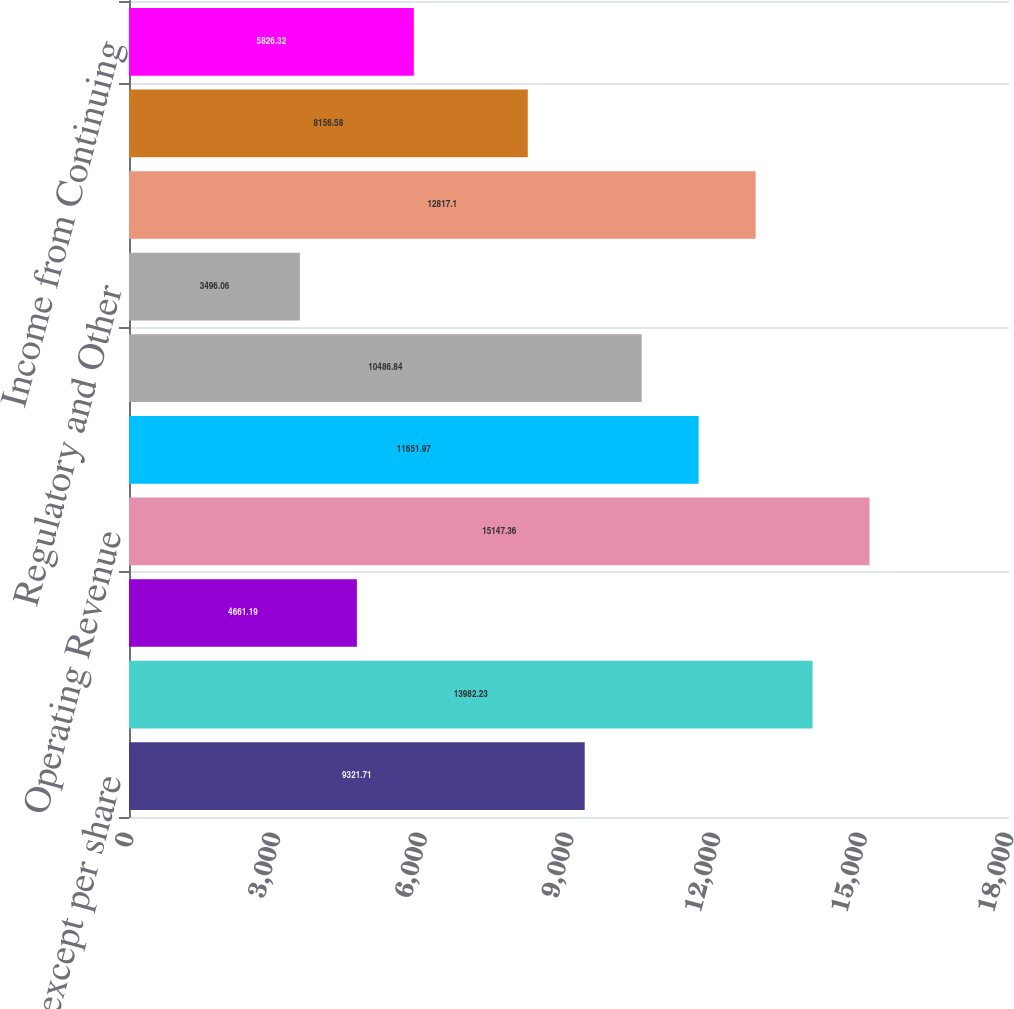Convert chart to OTSL. <chart><loc_0><loc_0><loc_500><loc_500><bar_chart><fcel>(In millions except per share<fcel>Service Revenue<fcel>Investment Income (Loss)<fcel>Operating Revenue<fcel>Compensation and Benefits<fcel>Other Operating Expenses<fcel>Regulatory and Other<fcel>Operating Expenses<fcel>Operating Income<fcel>Income from Continuing<nl><fcel>9321.71<fcel>13982.2<fcel>4661.19<fcel>15147.4<fcel>11652<fcel>10486.8<fcel>3496.06<fcel>12817.1<fcel>8156.58<fcel>5826.32<nl></chart> 